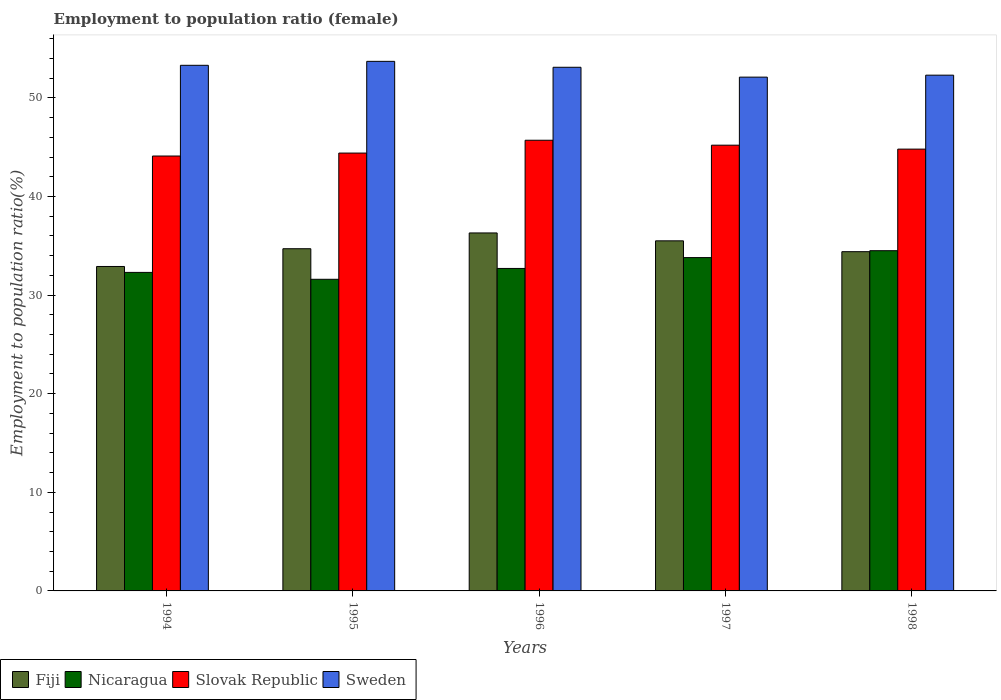How many different coloured bars are there?
Your response must be concise. 4. How many groups of bars are there?
Your answer should be very brief. 5. Are the number of bars on each tick of the X-axis equal?
Your response must be concise. Yes. How many bars are there on the 2nd tick from the left?
Ensure brevity in your answer.  4. What is the employment to population ratio in Sweden in 1998?
Make the answer very short. 52.3. Across all years, what is the maximum employment to population ratio in Nicaragua?
Your response must be concise. 34.5. Across all years, what is the minimum employment to population ratio in Nicaragua?
Offer a terse response. 31.6. What is the total employment to population ratio in Sweden in the graph?
Keep it short and to the point. 264.5. What is the difference between the employment to population ratio in Slovak Republic in 1994 and that in 1995?
Offer a terse response. -0.3. What is the difference between the employment to population ratio in Fiji in 1997 and the employment to population ratio in Nicaragua in 1996?
Make the answer very short. 2.8. What is the average employment to population ratio in Nicaragua per year?
Make the answer very short. 32.98. In the year 1998, what is the difference between the employment to population ratio in Fiji and employment to population ratio in Nicaragua?
Provide a succinct answer. -0.1. In how many years, is the employment to population ratio in Sweden greater than 6 %?
Offer a terse response. 5. What is the ratio of the employment to population ratio in Sweden in 1997 to that in 1998?
Give a very brief answer. 1. Is the difference between the employment to population ratio in Fiji in 1994 and 1997 greater than the difference between the employment to population ratio in Nicaragua in 1994 and 1997?
Your answer should be very brief. No. What is the difference between the highest and the lowest employment to population ratio in Nicaragua?
Provide a short and direct response. 2.9. Is it the case that in every year, the sum of the employment to population ratio in Slovak Republic and employment to population ratio in Sweden is greater than the sum of employment to population ratio in Nicaragua and employment to population ratio in Fiji?
Make the answer very short. Yes. What does the 2nd bar from the left in 1995 represents?
Keep it short and to the point. Nicaragua. What does the 2nd bar from the right in 1998 represents?
Your answer should be compact. Slovak Republic. How many bars are there?
Ensure brevity in your answer.  20. How many years are there in the graph?
Offer a very short reply. 5. What is the difference between two consecutive major ticks on the Y-axis?
Make the answer very short. 10. Does the graph contain any zero values?
Keep it short and to the point. No. Does the graph contain grids?
Provide a short and direct response. No. How many legend labels are there?
Give a very brief answer. 4. What is the title of the graph?
Keep it short and to the point. Employment to population ratio (female). What is the label or title of the X-axis?
Keep it short and to the point. Years. What is the label or title of the Y-axis?
Offer a terse response. Employment to population ratio(%). What is the Employment to population ratio(%) of Fiji in 1994?
Offer a very short reply. 32.9. What is the Employment to population ratio(%) of Nicaragua in 1994?
Your answer should be compact. 32.3. What is the Employment to population ratio(%) in Slovak Republic in 1994?
Ensure brevity in your answer.  44.1. What is the Employment to population ratio(%) of Sweden in 1994?
Keep it short and to the point. 53.3. What is the Employment to population ratio(%) in Fiji in 1995?
Make the answer very short. 34.7. What is the Employment to population ratio(%) in Nicaragua in 1995?
Make the answer very short. 31.6. What is the Employment to population ratio(%) of Slovak Republic in 1995?
Provide a succinct answer. 44.4. What is the Employment to population ratio(%) of Sweden in 1995?
Keep it short and to the point. 53.7. What is the Employment to population ratio(%) of Fiji in 1996?
Offer a terse response. 36.3. What is the Employment to population ratio(%) in Nicaragua in 1996?
Keep it short and to the point. 32.7. What is the Employment to population ratio(%) of Slovak Republic in 1996?
Offer a very short reply. 45.7. What is the Employment to population ratio(%) of Sweden in 1996?
Your answer should be very brief. 53.1. What is the Employment to population ratio(%) of Fiji in 1997?
Your response must be concise. 35.5. What is the Employment to population ratio(%) of Nicaragua in 1997?
Provide a succinct answer. 33.8. What is the Employment to population ratio(%) of Slovak Republic in 1997?
Offer a very short reply. 45.2. What is the Employment to population ratio(%) in Sweden in 1997?
Provide a short and direct response. 52.1. What is the Employment to population ratio(%) in Fiji in 1998?
Your answer should be compact. 34.4. What is the Employment to population ratio(%) of Nicaragua in 1998?
Ensure brevity in your answer.  34.5. What is the Employment to population ratio(%) of Slovak Republic in 1998?
Your answer should be compact. 44.8. What is the Employment to population ratio(%) of Sweden in 1998?
Provide a short and direct response. 52.3. Across all years, what is the maximum Employment to population ratio(%) in Fiji?
Keep it short and to the point. 36.3. Across all years, what is the maximum Employment to population ratio(%) of Nicaragua?
Your response must be concise. 34.5. Across all years, what is the maximum Employment to population ratio(%) of Slovak Republic?
Your response must be concise. 45.7. Across all years, what is the maximum Employment to population ratio(%) of Sweden?
Your answer should be compact. 53.7. Across all years, what is the minimum Employment to population ratio(%) in Fiji?
Give a very brief answer. 32.9. Across all years, what is the minimum Employment to population ratio(%) in Nicaragua?
Ensure brevity in your answer.  31.6. Across all years, what is the minimum Employment to population ratio(%) in Slovak Republic?
Make the answer very short. 44.1. Across all years, what is the minimum Employment to population ratio(%) of Sweden?
Ensure brevity in your answer.  52.1. What is the total Employment to population ratio(%) in Fiji in the graph?
Give a very brief answer. 173.8. What is the total Employment to population ratio(%) in Nicaragua in the graph?
Offer a very short reply. 164.9. What is the total Employment to population ratio(%) in Slovak Republic in the graph?
Your response must be concise. 224.2. What is the total Employment to population ratio(%) of Sweden in the graph?
Make the answer very short. 264.5. What is the difference between the Employment to population ratio(%) of Nicaragua in 1994 and that in 1995?
Your answer should be compact. 0.7. What is the difference between the Employment to population ratio(%) in Nicaragua in 1994 and that in 1996?
Offer a very short reply. -0.4. What is the difference between the Employment to population ratio(%) in Slovak Republic in 1994 and that in 1996?
Give a very brief answer. -1.6. What is the difference between the Employment to population ratio(%) of Sweden in 1994 and that in 1996?
Offer a terse response. 0.2. What is the difference between the Employment to population ratio(%) in Fiji in 1994 and that in 1997?
Ensure brevity in your answer.  -2.6. What is the difference between the Employment to population ratio(%) in Slovak Republic in 1994 and that in 1997?
Give a very brief answer. -1.1. What is the difference between the Employment to population ratio(%) of Sweden in 1994 and that in 1997?
Your response must be concise. 1.2. What is the difference between the Employment to population ratio(%) of Nicaragua in 1994 and that in 1998?
Give a very brief answer. -2.2. What is the difference between the Employment to population ratio(%) in Sweden in 1994 and that in 1998?
Ensure brevity in your answer.  1. What is the difference between the Employment to population ratio(%) in Fiji in 1995 and that in 1996?
Your answer should be very brief. -1.6. What is the difference between the Employment to population ratio(%) in Slovak Republic in 1995 and that in 1996?
Provide a short and direct response. -1.3. What is the difference between the Employment to population ratio(%) of Fiji in 1995 and that in 1997?
Offer a very short reply. -0.8. What is the difference between the Employment to population ratio(%) in Nicaragua in 1995 and that in 1997?
Keep it short and to the point. -2.2. What is the difference between the Employment to population ratio(%) of Slovak Republic in 1995 and that in 1998?
Give a very brief answer. -0.4. What is the difference between the Employment to population ratio(%) in Nicaragua in 1996 and that in 1997?
Give a very brief answer. -1.1. What is the difference between the Employment to population ratio(%) in Slovak Republic in 1996 and that in 1997?
Ensure brevity in your answer.  0.5. What is the difference between the Employment to population ratio(%) of Sweden in 1996 and that in 1997?
Give a very brief answer. 1. What is the difference between the Employment to population ratio(%) of Slovak Republic in 1996 and that in 1998?
Your answer should be very brief. 0.9. What is the difference between the Employment to population ratio(%) of Fiji in 1997 and that in 1998?
Your answer should be very brief. 1.1. What is the difference between the Employment to population ratio(%) in Slovak Republic in 1997 and that in 1998?
Give a very brief answer. 0.4. What is the difference between the Employment to population ratio(%) in Fiji in 1994 and the Employment to population ratio(%) in Sweden in 1995?
Provide a short and direct response. -20.8. What is the difference between the Employment to population ratio(%) in Nicaragua in 1994 and the Employment to population ratio(%) in Sweden in 1995?
Ensure brevity in your answer.  -21.4. What is the difference between the Employment to population ratio(%) of Fiji in 1994 and the Employment to population ratio(%) of Nicaragua in 1996?
Offer a terse response. 0.2. What is the difference between the Employment to population ratio(%) in Fiji in 1994 and the Employment to population ratio(%) in Sweden in 1996?
Make the answer very short. -20.2. What is the difference between the Employment to population ratio(%) in Nicaragua in 1994 and the Employment to population ratio(%) in Sweden in 1996?
Make the answer very short. -20.8. What is the difference between the Employment to population ratio(%) in Fiji in 1994 and the Employment to population ratio(%) in Sweden in 1997?
Offer a very short reply. -19.2. What is the difference between the Employment to population ratio(%) in Nicaragua in 1994 and the Employment to population ratio(%) in Slovak Republic in 1997?
Offer a very short reply. -12.9. What is the difference between the Employment to population ratio(%) in Nicaragua in 1994 and the Employment to population ratio(%) in Sweden in 1997?
Offer a terse response. -19.8. What is the difference between the Employment to population ratio(%) of Slovak Republic in 1994 and the Employment to population ratio(%) of Sweden in 1997?
Your answer should be very brief. -8. What is the difference between the Employment to population ratio(%) of Fiji in 1994 and the Employment to population ratio(%) of Slovak Republic in 1998?
Give a very brief answer. -11.9. What is the difference between the Employment to population ratio(%) of Fiji in 1994 and the Employment to population ratio(%) of Sweden in 1998?
Your answer should be compact. -19.4. What is the difference between the Employment to population ratio(%) in Nicaragua in 1994 and the Employment to population ratio(%) in Slovak Republic in 1998?
Offer a very short reply. -12.5. What is the difference between the Employment to population ratio(%) of Slovak Republic in 1994 and the Employment to population ratio(%) of Sweden in 1998?
Your answer should be compact. -8.2. What is the difference between the Employment to population ratio(%) in Fiji in 1995 and the Employment to population ratio(%) in Slovak Republic in 1996?
Offer a very short reply. -11. What is the difference between the Employment to population ratio(%) in Fiji in 1995 and the Employment to population ratio(%) in Sweden in 1996?
Give a very brief answer. -18.4. What is the difference between the Employment to population ratio(%) in Nicaragua in 1995 and the Employment to population ratio(%) in Slovak Republic in 1996?
Give a very brief answer. -14.1. What is the difference between the Employment to population ratio(%) of Nicaragua in 1995 and the Employment to population ratio(%) of Sweden in 1996?
Your answer should be compact. -21.5. What is the difference between the Employment to population ratio(%) of Fiji in 1995 and the Employment to population ratio(%) of Nicaragua in 1997?
Make the answer very short. 0.9. What is the difference between the Employment to population ratio(%) of Fiji in 1995 and the Employment to population ratio(%) of Slovak Republic in 1997?
Make the answer very short. -10.5. What is the difference between the Employment to population ratio(%) of Fiji in 1995 and the Employment to population ratio(%) of Sweden in 1997?
Keep it short and to the point. -17.4. What is the difference between the Employment to population ratio(%) in Nicaragua in 1995 and the Employment to population ratio(%) in Slovak Republic in 1997?
Provide a succinct answer. -13.6. What is the difference between the Employment to population ratio(%) of Nicaragua in 1995 and the Employment to population ratio(%) of Sweden in 1997?
Provide a succinct answer. -20.5. What is the difference between the Employment to population ratio(%) in Fiji in 1995 and the Employment to population ratio(%) in Sweden in 1998?
Your answer should be very brief. -17.6. What is the difference between the Employment to population ratio(%) of Nicaragua in 1995 and the Employment to population ratio(%) of Sweden in 1998?
Your answer should be very brief. -20.7. What is the difference between the Employment to population ratio(%) of Slovak Republic in 1995 and the Employment to population ratio(%) of Sweden in 1998?
Make the answer very short. -7.9. What is the difference between the Employment to population ratio(%) in Fiji in 1996 and the Employment to population ratio(%) in Nicaragua in 1997?
Make the answer very short. 2.5. What is the difference between the Employment to population ratio(%) in Fiji in 1996 and the Employment to population ratio(%) in Slovak Republic in 1997?
Make the answer very short. -8.9. What is the difference between the Employment to population ratio(%) in Fiji in 1996 and the Employment to population ratio(%) in Sweden in 1997?
Ensure brevity in your answer.  -15.8. What is the difference between the Employment to population ratio(%) of Nicaragua in 1996 and the Employment to population ratio(%) of Slovak Republic in 1997?
Offer a very short reply. -12.5. What is the difference between the Employment to population ratio(%) in Nicaragua in 1996 and the Employment to population ratio(%) in Sweden in 1997?
Provide a succinct answer. -19.4. What is the difference between the Employment to population ratio(%) of Slovak Republic in 1996 and the Employment to population ratio(%) of Sweden in 1997?
Provide a succinct answer. -6.4. What is the difference between the Employment to population ratio(%) in Fiji in 1996 and the Employment to population ratio(%) in Nicaragua in 1998?
Make the answer very short. 1.8. What is the difference between the Employment to population ratio(%) of Fiji in 1996 and the Employment to population ratio(%) of Slovak Republic in 1998?
Make the answer very short. -8.5. What is the difference between the Employment to population ratio(%) in Fiji in 1996 and the Employment to population ratio(%) in Sweden in 1998?
Offer a very short reply. -16. What is the difference between the Employment to population ratio(%) in Nicaragua in 1996 and the Employment to population ratio(%) in Slovak Republic in 1998?
Your response must be concise. -12.1. What is the difference between the Employment to population ratio(%) of Nicaragua in 1996 and the Employment to population ratio(%) of Sweden in 1998?
Keep it short and to the point. -19.6. What is the difference between the Employment to population ratio(%) of Fiji in 1997 and the Employment to population ratio(%) of Nicaragua in 1998?
Provide a succinct answer. 1. What is the difference between the Employment to population ratio(%) in Fiji in 1997 and the Employment to population ratio(%) in Slovak Republic in 1998?
Your answer should be very brief. -9.3. What is the difference between the Employment to population ratio(%) of Fiji in 1997 and the Employment to population ratio(%) of Sweden in 1998?
Offer a terse response. -16.8. What is the difference between the Employment to population ratio(%) of Nicaragua in 1997 and the Employment to population ratio(%) of Sweden in 1998?
Make the answer very short. -18.5. What is the average Employment to population ratio(%) of Fiji per year?
Offer a very short reply. 34.76. What is the average Employment to population ratio(%) in Nicaragua per year?
Ensure brevity in your answer.  32.98. What is the average Employment to population ratio(%) in Slovak Republic per year?
Ensure brevity in your answer.  44.84. What is the average Employment to population ratio(%) of Sweden per year?
Your answer should be very brief. 52.9. In the year 1994, what is the difference between the Employment to population ratio(%) in Fiji and Employment to population ratio(%) in Nicaragua?
Provide a succinct answer. 0.6. In the year 1994, what is the difference between the Employment to population ratio(%) of Fiji and Employment to population ratio(%) of Sweden?
Your answer should be compact. -20.4. In the year 1995, what is the difference between the Employment to population ratio(%) of Fiji and Employment to population ratio(%) of Nicaragua?
Provide a short and direct response. 3.1. In the year 1995, what is the difference between the Employment to population ratio(%) in Fiji and Employment to population ratio(%) in Slovak Republic?
Offer a terse response. -9.7. In the year 1995, what is the difference between the Employment to population ratio(%) in Nicaragua and Employment to population ratio(%) in Sweden?
Offer a very short reply. -22.1. In the year 1996, what is the difference between the Employment to population ratio(%) in Fiji and Employment to population ratio(%) in Nicaragua?
Provide a succinct answer. 3.6. In the year 1996, what is the difference between the Employment to population ratio(%) in Fiji and Employment to population ratio(%) in Sweden?
Ensure brevity in your answer.  -16.8. In the year 1996, what is the difference between the Employment to population ratio(%) in Nicaragua and Employment to population ratio(%) in Sweden?
Provide a short and direct response. -20.4. In the year 1996, what is the difference between the Employment to population ratio(%) of Slovak Republic and Employment to population ratio(%) of Sweden?
Provide a short and direct response. -7.4. In the year 1997, what is the difference between the Employment to population ratio(%) in Fiji and Employment to population ratio(%) in Slovak Republic?
Provide a succinct answer. -9.7. In the year 1997, what is the difference between the Employment to population ratio(%) of Fiji and Employment to population ratio(%) of Sweden?
Your answer should be very brief. -16.6. In the year 1997, what is the difference between the Employment to population ratio(%) of Nicaragua and Employment to population ratio(%) of Slovak Republic?
Offer a terse response. -11.4. In the year 1997, what is the difference between the Employment to population ratio(%) in Nicaragua and Employment to population ratio(%) in Sweden?
Provide a short and direct response. -18.3. In the year 1998, what is the difference between the Employment to population ratio(%) of Fiji and Employment to population ratio(%) of Slovak Republic?
Keep it short and to the point. -10.4. In the year 1998, what is the difference between the Employment to population ratio(%) in Fiji and Employment to population ratio(%) in Sweden?
Your answer should be very brief. -17.9. In the year 1998, what is the difference between the Employment to population ratio(%) of Nicaragua and Employment to population ratio(%) of Slovak Republic?
Give a very brief answer. -10.3. In the year 1998, what is the difference between the Employment to population ratio(%) in Nicaragua and Employment to population ratio(%) in Sweden?
Offer a terse response. -17.8. In the year 1998, what is the difference between the Employment to population ratio(%) in Slovak Republic and Employment to population ratio(%) in Sweden?
Offer a terse response. -7.5. What is the ratio of the Employment to population ratio(%) in Fiji in 1994 to that in 1995?
Keep it short and to the point. 0.95. What is the ratio of the Employment to population ratio(%) of Nicaragua in 1994 to that in 1995?
Your answer should be compact. 1.02. What is the ratio of the Employment to population ratio(%) in Fiji in 1994 to that in 1996?
Offer a terse response. 0.91. What is the ratio of the Employment to population ratio(%) in Nicaragua in 1994 to that in 1996?
Your answer should be very brief. 0.99. What is the ratio of the Employment to population ratio(%) in Sweden in 1994 to that in 1996?
Your answer should be very brief. 1. What is the ratio of the Employment to population ratio(%) in Fiji in 1994 to that in 1997?
Make the answer very short. 0.93. What is the ratio of the Employment to population ratio(%) in Nicaragua in 1994 to that in 1997?
Give a very brief answer. 0.96. What is the ratio of the Employment to population ratio(%) of Slovak Republic in 1994 to that in 1997?
Give a very brief answer. 0.98. What is the ratio of the Employment to population ratio(%) of Fiji in 1994 to that in 1998?
Your answer should be very brief. 0.96. What is the ratio of the Employment to population ratio(%) in Nicaragua in 1994 to that in 1998?
Make the answer very short. 0.94. What is the ratio of the Employment to population ratio(%) of Slovak Republic in 1994 to that in 1998?
Offer a very short reply. 0.98. What is the ratio of the Employment to population ratio(%) of Sweden in 1994 to that in 1998?
Provide a short and direct response. 1.02. What is the ratio of the Employment to population ratio(%) of Fiji in 1995 to that in 1996?
Offer a terse response. 0.96. What is the ratio of the Employment to population ratio(%) in Nicaragua in 1995 to that in 1996?
Your response must be concise. 0.97. What is the ratio of the Employment to population ratio(%) of Slovak Republic in 1995 to that in 1996?
Offer a terse response. 0.97. What is the ratio of the Employment to population ratio(%) of Sweden in 1995 to that in 1996?
Provide a short and direct response. 1.01. What is the ratio of the Employment to population ratio(%) in Fiji in 1995 to that in 1997?
Give a very brief answer. 0.98. What is the ratio of the Employment to population ratio(%) of Nicaragua in 1995 to that in 1997?
Provide a succinct answer. 0.93. What is the ratio of the Employment to population ratio(%) in Slovak Republic in 1995 to that in 1997?
Offer a very short reply. 0.98. What is the ratio of the Employment to population ratio(%) of Sweden in 1995 to that in 1997?
Provide a succinct answer. 1.03. What is the ratio of the Employment to population ratio(%) of Fiji in 1995 to that in 1998?
Your answer should be very brief. 1.01. What is the ratio of the Employment to population ratio(%) of Nicaragua in 1995 to that in 1998?
Give a very brief answer. 0.92. What is the ratio of the Employment to population ratio(%) of Sweden in 1995 to that in 1998?
Make the answer very short. 1.03. What is the ratio of the Employment to population ratio(%) of Fiji in 1996 to that in 1997?
Make the answer very short. 1.02. What is the ratio of the Employment to population ratio(%) of Nicaragua in 1996 to that in 1997?
Your response must be concise. 0.97. What is the ratio of the Employment to population ratio(%) of Slovak Republic in 1996 to that in 1997?
Your response must be concise. 1.01. What is the ratio of the Employment to population ratio(%) of Sweden in 1996 to that in 1997?
Ensure brevity in your answer.  1.02. What is the ratio of the Employment to population ratio(%) in Fiji in 1996 to that in 1998?
Give a very brief answer. 1.06. What is the ratio of the Employment to population ratio(%) in Nicaragua in 1996 to that in 1998?
Provide a short and direct response. 0.95. What is the ratio of the Employment to population ratio(%) in Slovak Republic in 1996 to that in 1998?
Your answer should be very brief. 1.02. What is the ratio of the Employment to population ratio(%) in Sweden in 1996 to that in 1998?
Your answer should be very brief. 1.02. What is the ratio of the Employment to population ratio(%) in Fiji in 1997 to that in 1998?
Ensure brevity in your answer.  1.03. What is the ratio of the Employment to population ratio(%) of Nicaragua in 1997 to that in 1998?
Offer a very short reply. 0.98. What is the ratio of the Employment to population ratio(%) of Slovak Republic in 1997 to that in 1998?
Provide a short and direct response. 1.01. What is the ratio of the Employment to population ratio(%) of Sweden in 1997 to that in 1998?
Make the answer very short. 1. What is the difference between the highest and the second highest Employment to population ratio(%) in Nicaragua?
Ensure brevity in your answer.  0.7. What is the difference between the highest and the lowest Employment to population ratio(%) of Fiji?
Your answer should be compact. 3.4. 